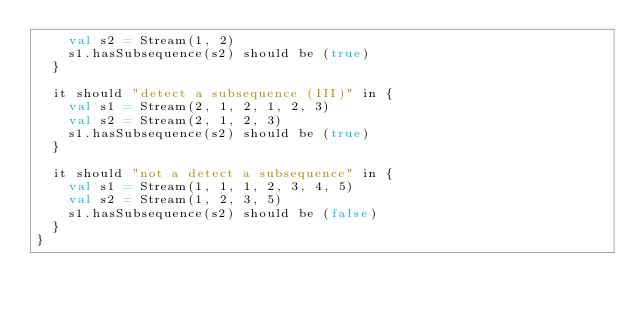<code> <loc_0><loc_0><loc_500><loc_500><_Scala_>    val s2 = Stream(1, 2)
    s1.hasSubsequence(s2) should be (true)
  }

  it should "detect a subsequence (III)" in {
    val s1 = Stream(2, 1, 2, 1, 2, 3)
    val s2 = Stream(2, 1, 2, 3)
    s1.hasSubsequence(s2) should be (true)
  }

  it should "not a detect a subsequence" in {
    val s1 = Stream(1, 1, 1, 2, 3, 4, 5)
    val s2 = Stream(1, 2, 3, 5)
    s1.hasSubsequence(s2) should be (false)
  }
}</code> 